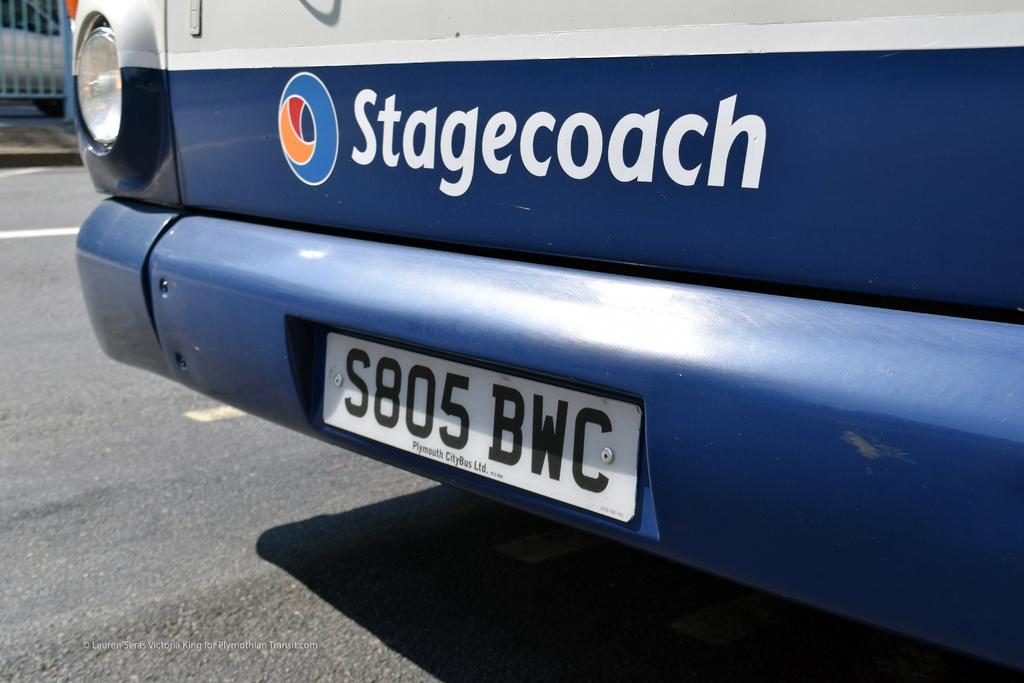Provide a one-sentence caption for the provided image. Stagecoach wrote on the front of a type of vehicle. 